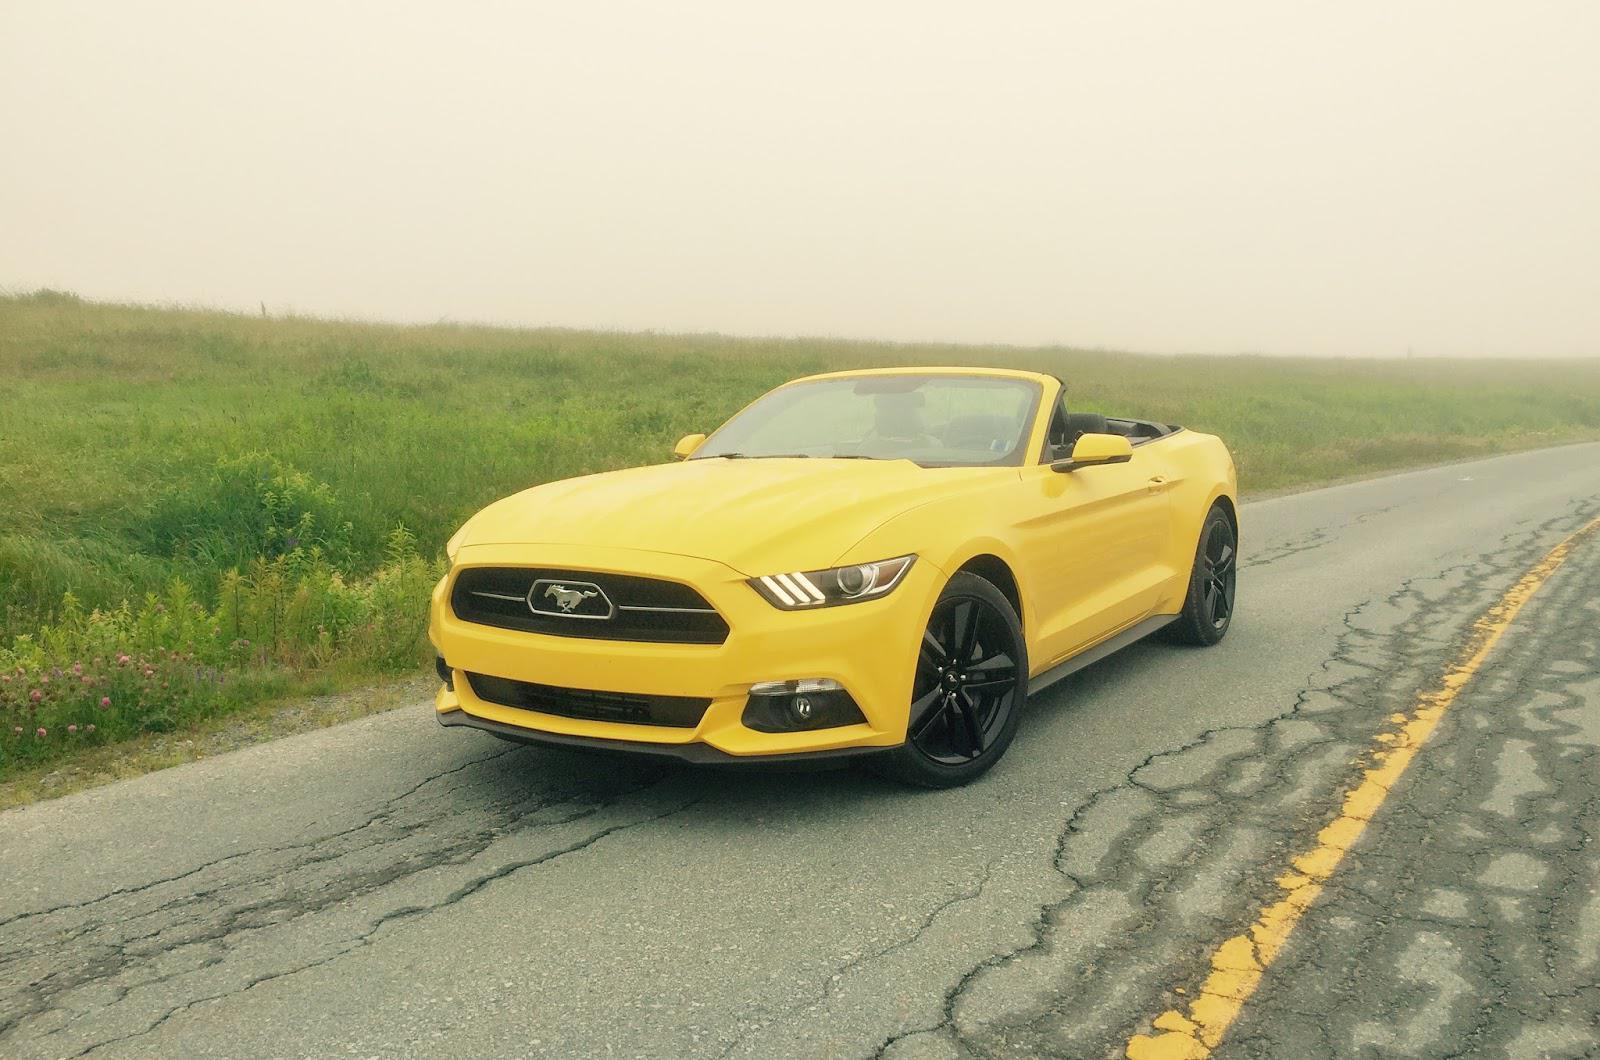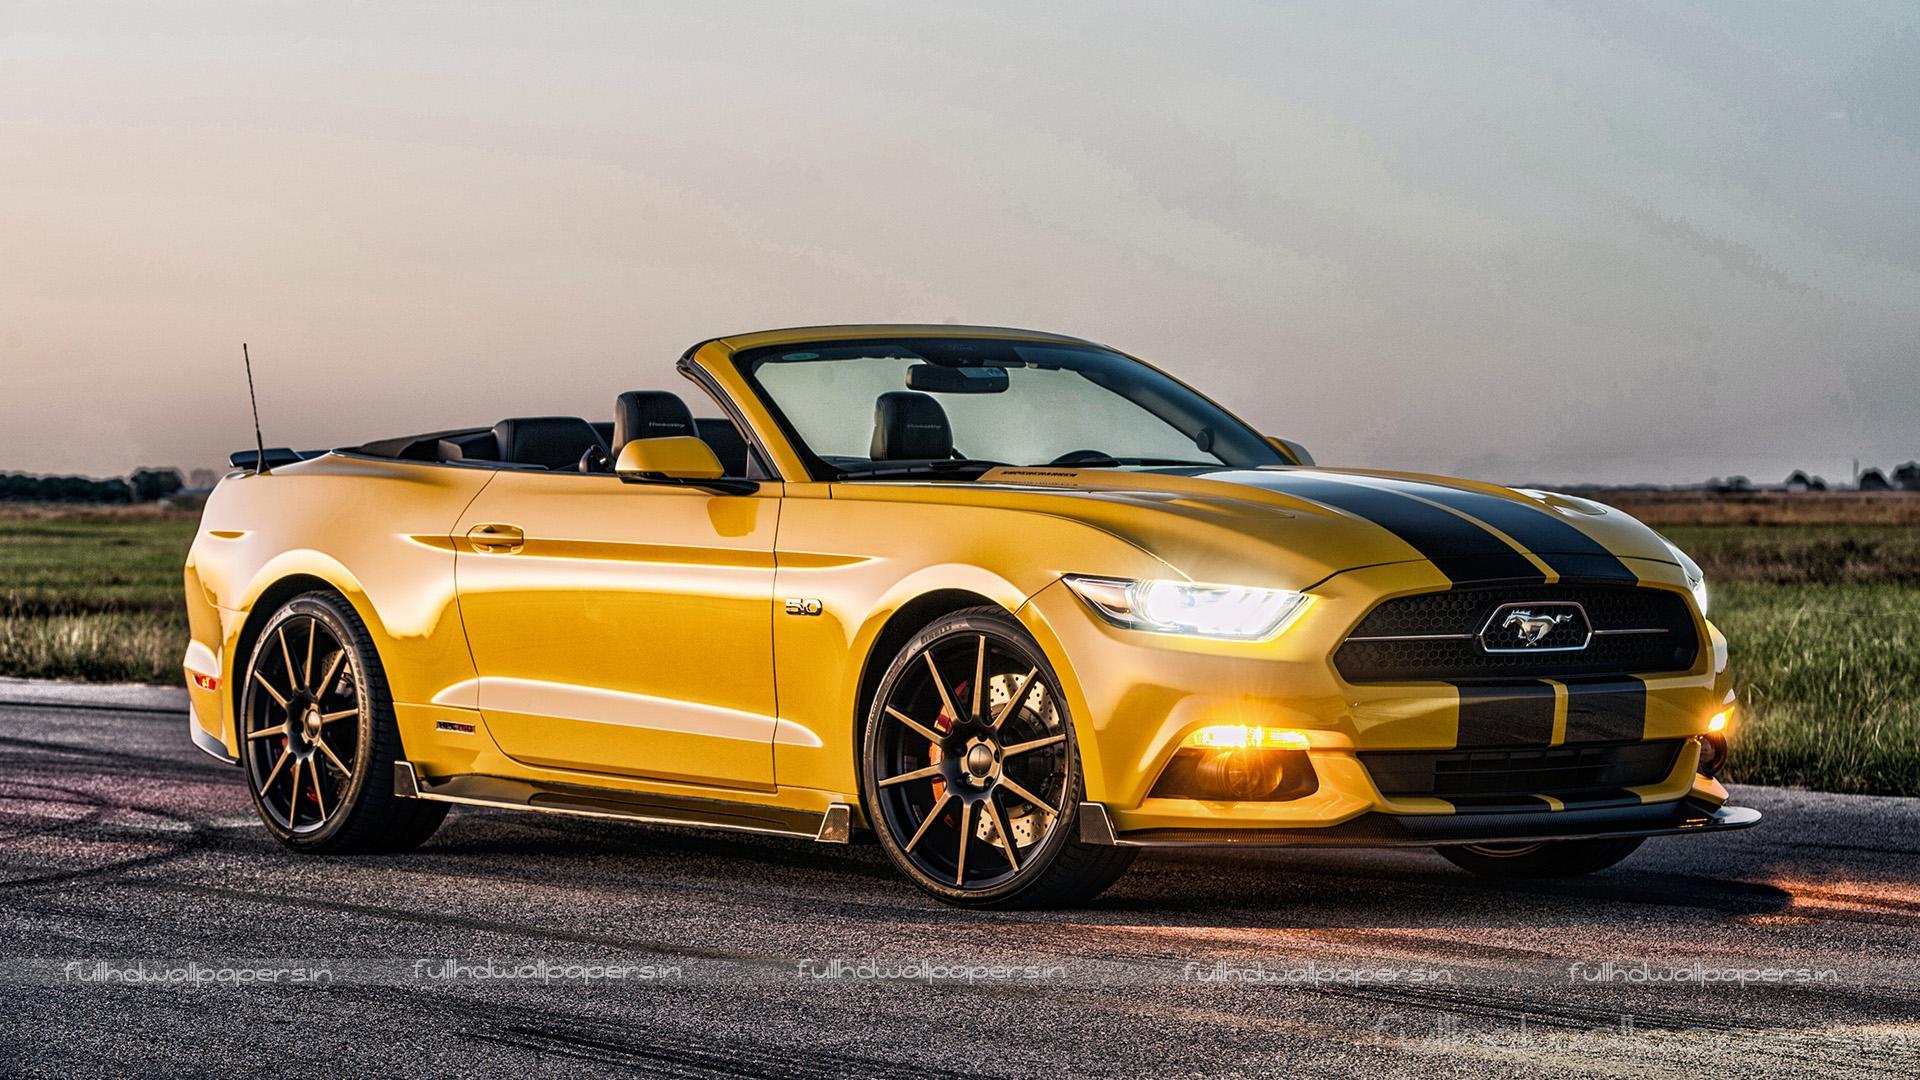The first image is the image on the left, the second image is the image on the right. Given the left and right images, does the statement "The right image contains one yellow car that is facing towards the right." hold true? Answer yes or no. Yes. The first image is the image on the left, the second image is the image on the right. For the images shown, is this caption "One image shows a leftward-angled yellow convertible without a hood stripe, and the other features a right-turned convertible with black stripes on its hood." true? Answer yes or no. Yes. 